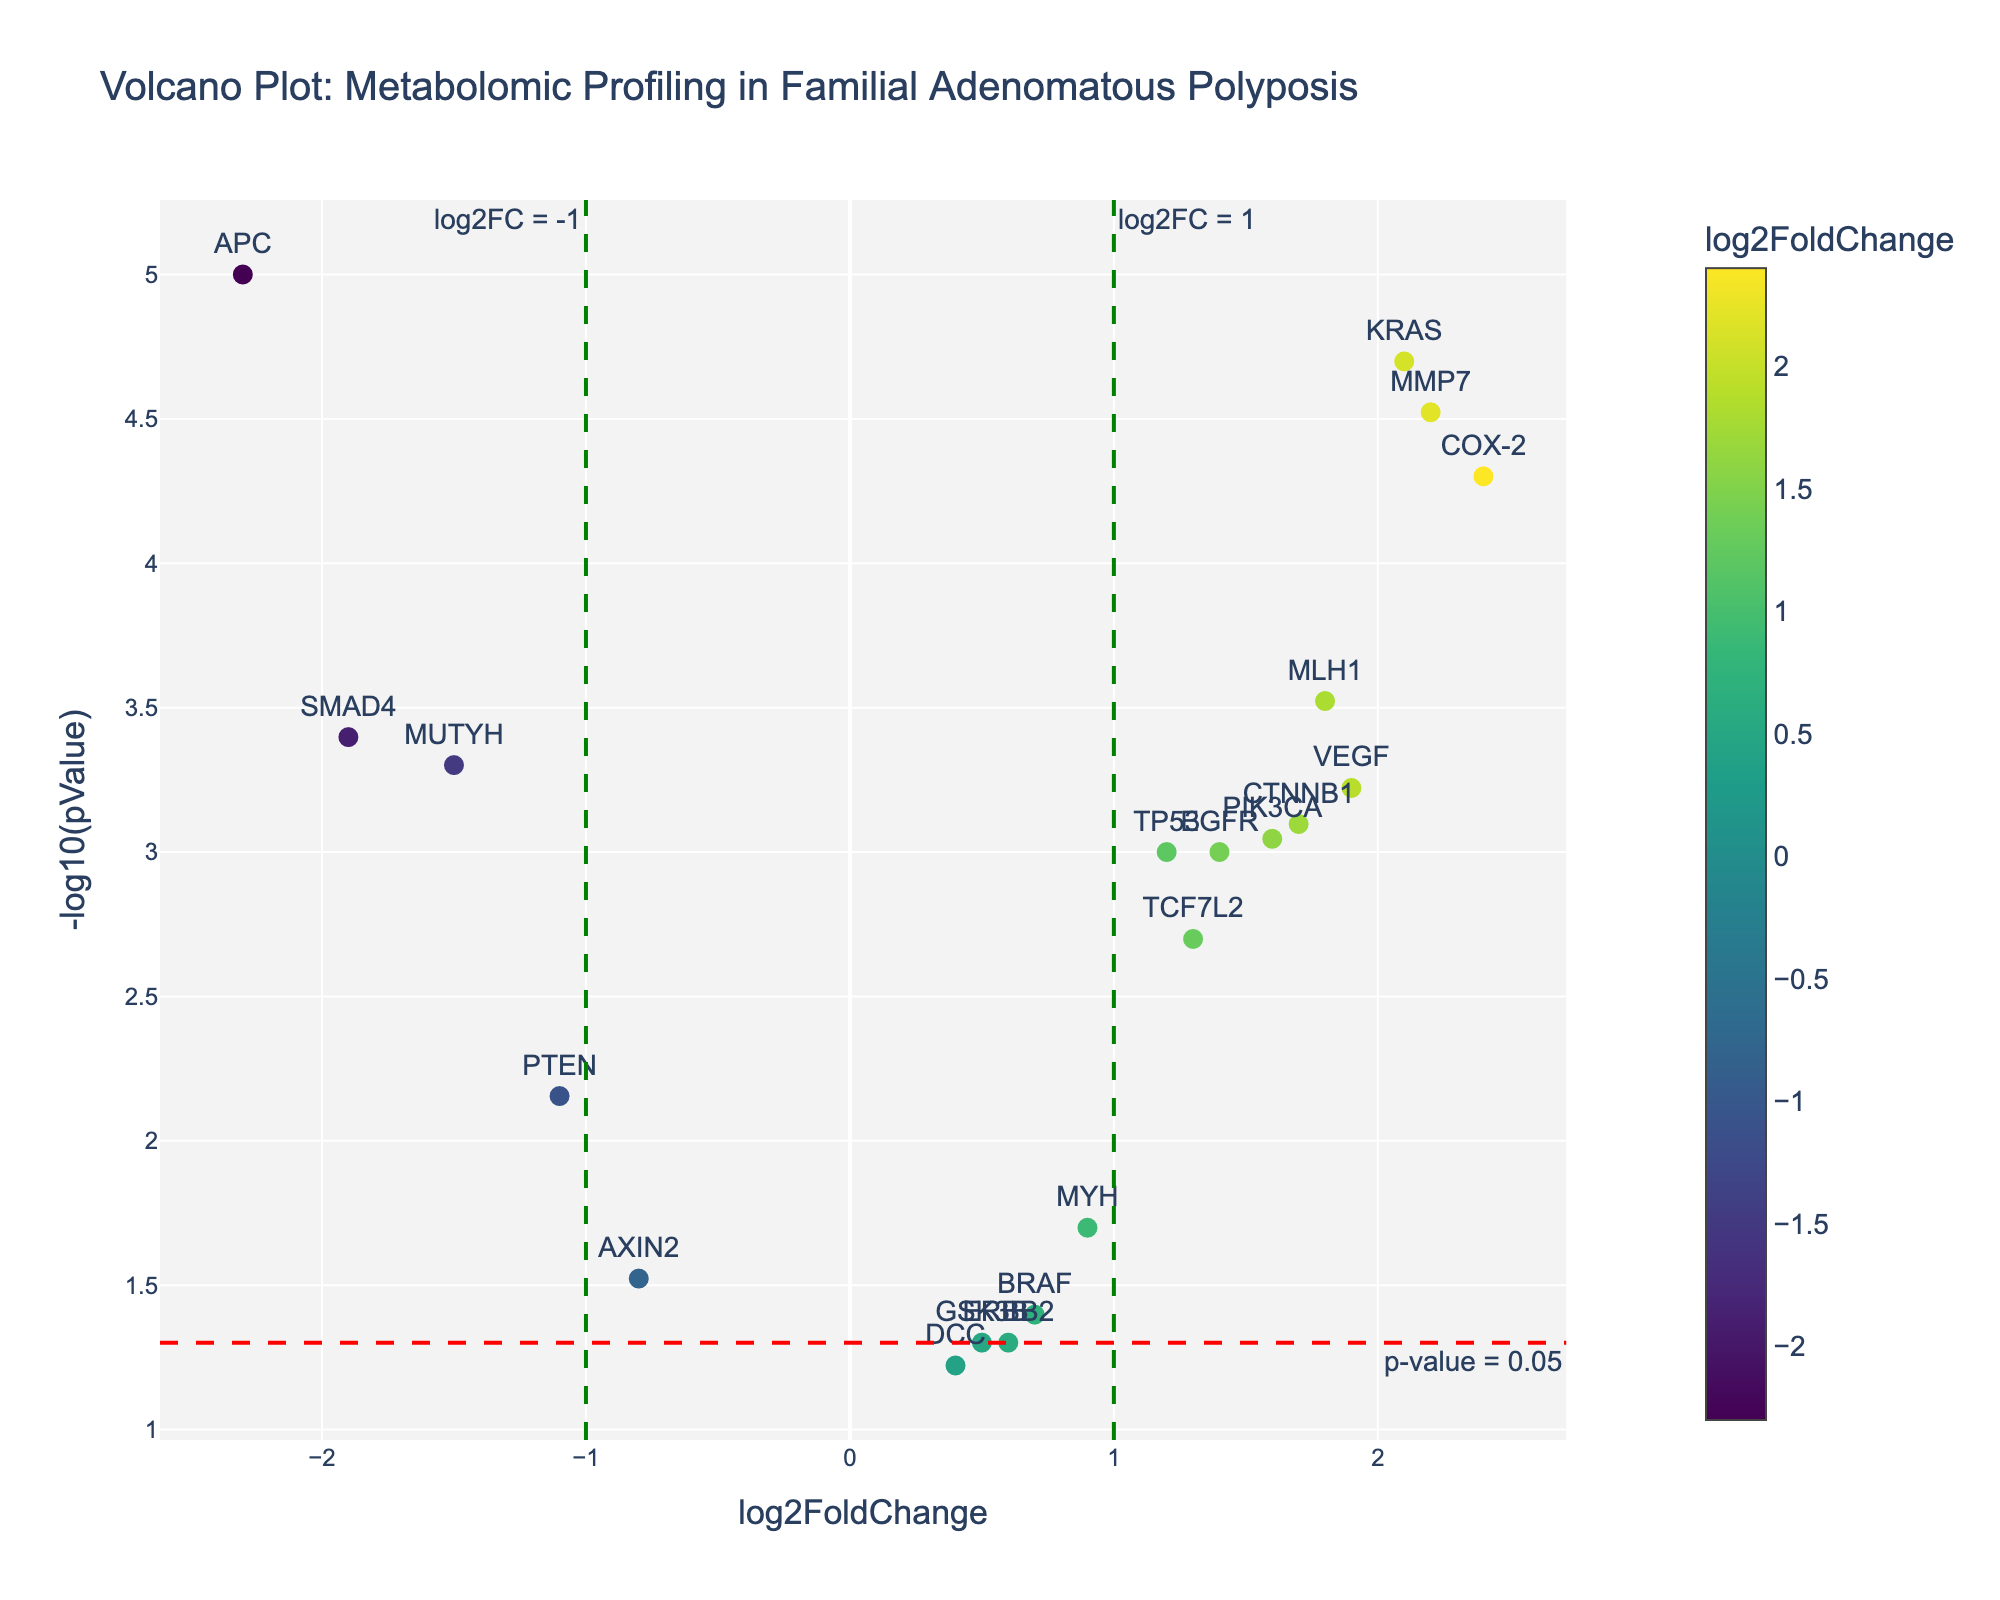What is the title of the plot? The title of the plot is located at the top of the figure, typically centered.
Answer: Volcano Plot: Metabolomic Profiling in Familial Adenomatous Polyposis What gene shows the most significant change in expression? By examining the y-axis representing -log10(pValue) and identifying the highest point on the plot, we can determine the most significant change in expression.
Answer: APC How many genes have a log2FoldChange greater than 1? Look at the x-axis for values greater than 1 and count the corresponding data points on the plot.
Answer: 6 Which gene has the highest log2FoldChange value? By identifying the data point farthest to the right on the x-axis and checking the corresponding gene label, we find the highest log2FoldChange value.
Answer: COX-2 What is the p-value threshold line indicated in the plot? The plot has a horizontal dashed line annotated, indicating the significance threshold.
Answer: 0.05 Which genes fall below the p-value threshold line? Identify the data points below the horizontal dashed line and list their corresponding gene labels.
Answer: MYH, AXIN2, GSK3B, DCC, BRAF, ERBB2 What is the log2FoldChange value for the gene CTNNB1? Locate the CTNNB1 data point and note its x-axis (log2FoldChange) value.
Answer: 1.7 How many genes exhibit a significant increase in expression with log2FoldChange greater than 1 and p-value less than 0.05? Look for data points beyond x = 1 and above the p-value threshold line (-log10(pValue) > -log10(0.05)).
Answer: 6 Between KRAS and TP53, which gene has a higher significance level? Compare the -log10(pValue) values (y-axis) of the KRAS and TP53 data points to see which is higher.
Answer: KRAS What are the coordinates of the gene MUTYH on the plot? Find MUTYH on the plot and note its (log2FoldChange, -log10(pValue)) coordinates.
Answer: (-1.5, 3.30) 